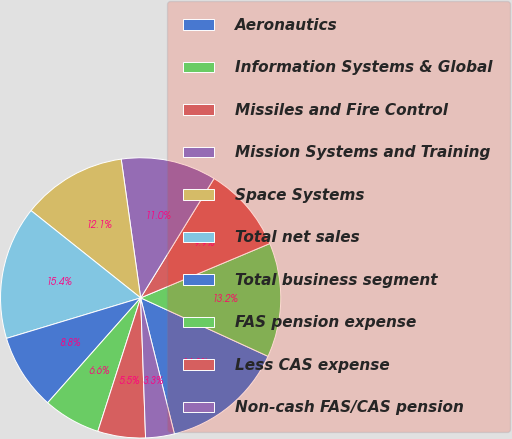Convert chart. <chart><loc_0><loc_0><loc_500><loc_500><pie_chart><fcel>Aeronautics<fcel>Information Systems & Global<fcel>Missiles and Fire Control<fcel>Mission Systems and Training<fcel>Space Systems<fcel>Total net sales<fcel>Total business segment<fcel>FAS pension expense<fcel>Less CAS expense<fcel>Non-cash FAS/CAS pension<nl><fcel>14.28%<fcel>13.18%<fcel>9.89%<fcel>10.99%<fcel>12.08%<fcel>15.37%<fcel>8.79%<fcel>6.6%<fcel>5.5%<fcel>3.31%<nl></chart> 